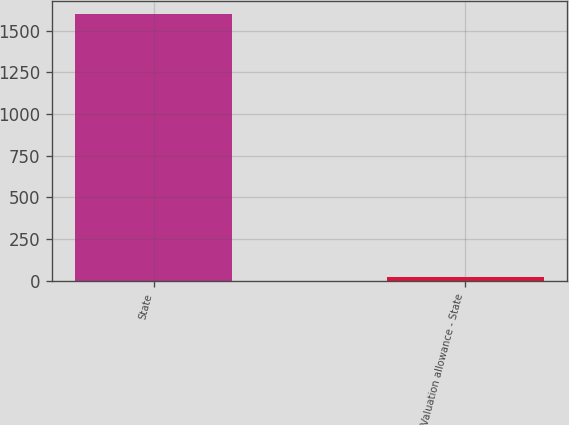Convert chart. <chart><loc_0><loc_0><loc_500><loc_500><bar_chart><fcel>State<fcel>Valuation allowance - State<nl><fcel>1600<fcel>21<nl></chart> 